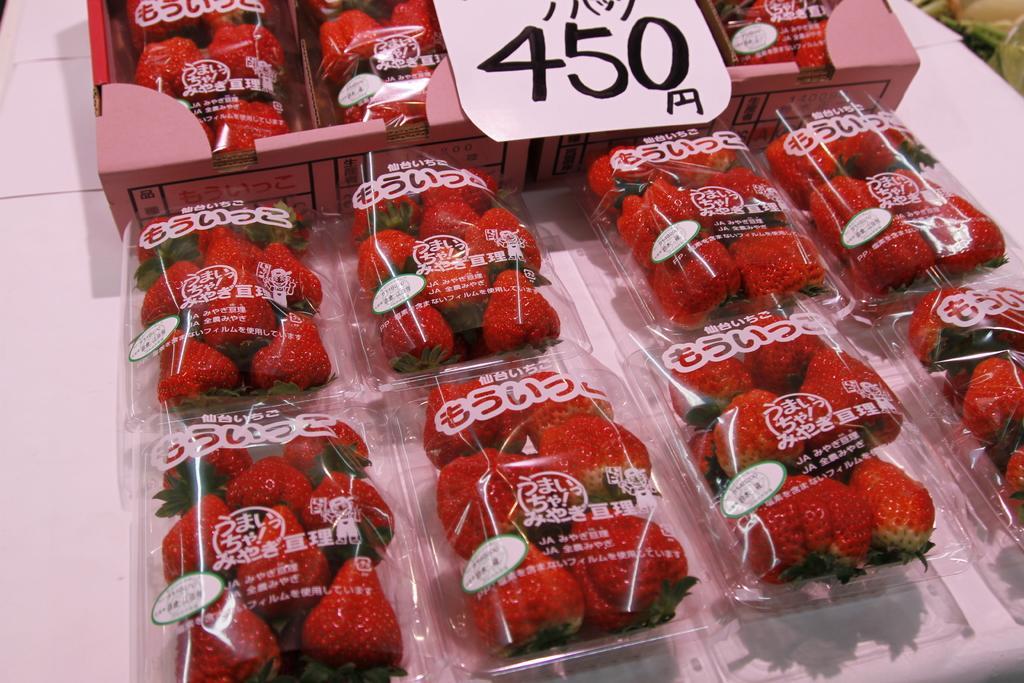Describe this image in one or two sentences. In this image there are strawberries in the boxes and also a price tag. 